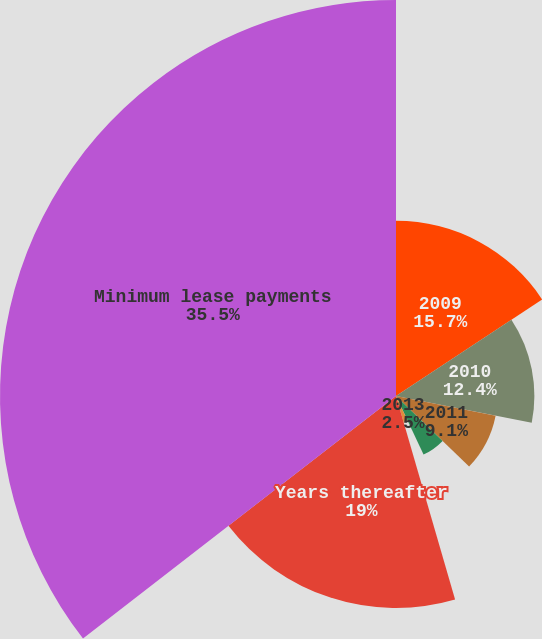Convert chart to OTSL. <chart><loc_0><loc_0><loc_500><loc_500><pie_chart><fcel>2009<fcel>2010<fcel>2011<fcel>2012<fcel>2013<fcel>Years thereafter<fcel>Minimum lease payments<nl><fcel>15.7%<fcel>12.4%<fcel>9.1%<fcel>5.8%<fcel>2.5%<fcel>19.0%<fcel>35.49%<nl></chart> 